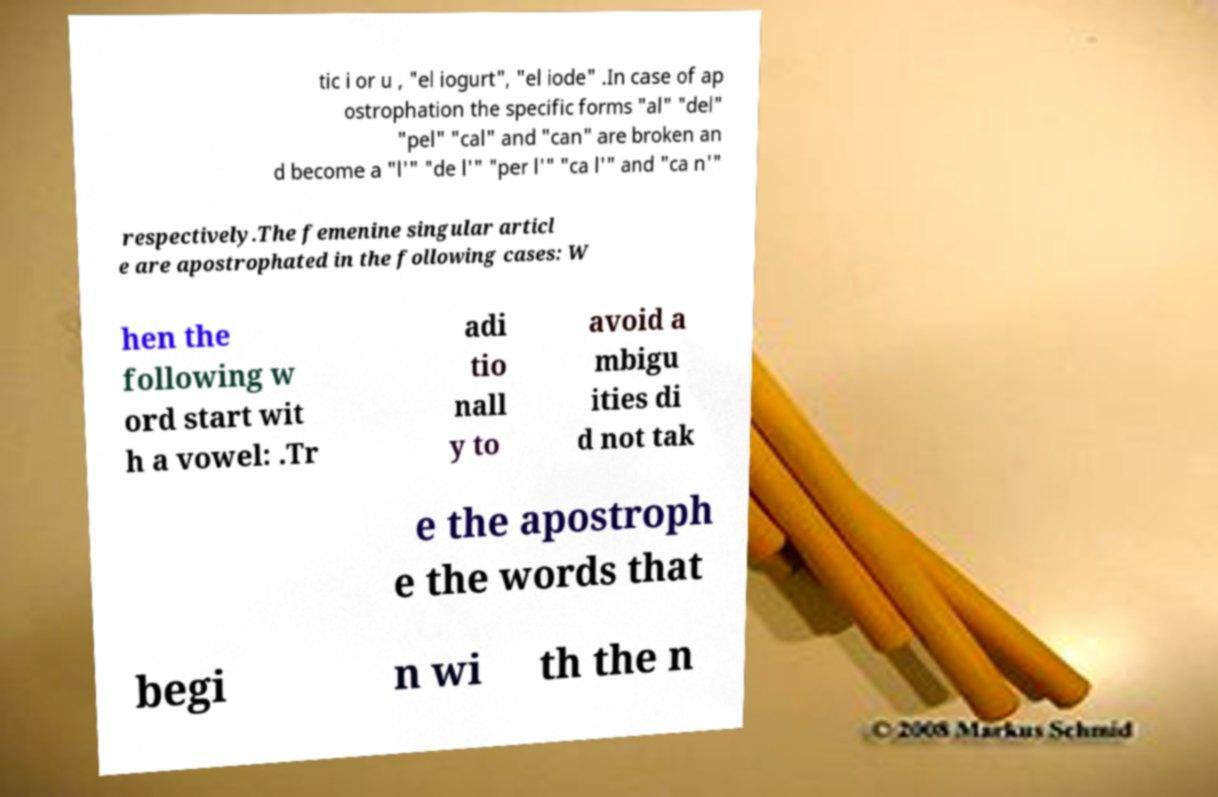Please identify and transcribe the text found in this image. tic i or u , "el iogurt", "el iode" .In case of ap ostrophation the specific forms "al" "del" "pel" "cal" and "can" are broken an d become a "l'" "de l'" "per l'" "ca l'" and "ca n'" respectively.The femenine singular articl e are apostrophated in the following cases: W hen the following w ord start wit h a vowel: .Tr adi tio nall y to avoid a mbigu ities di d not tak e the apostroph e the words that begi n wi th the n 